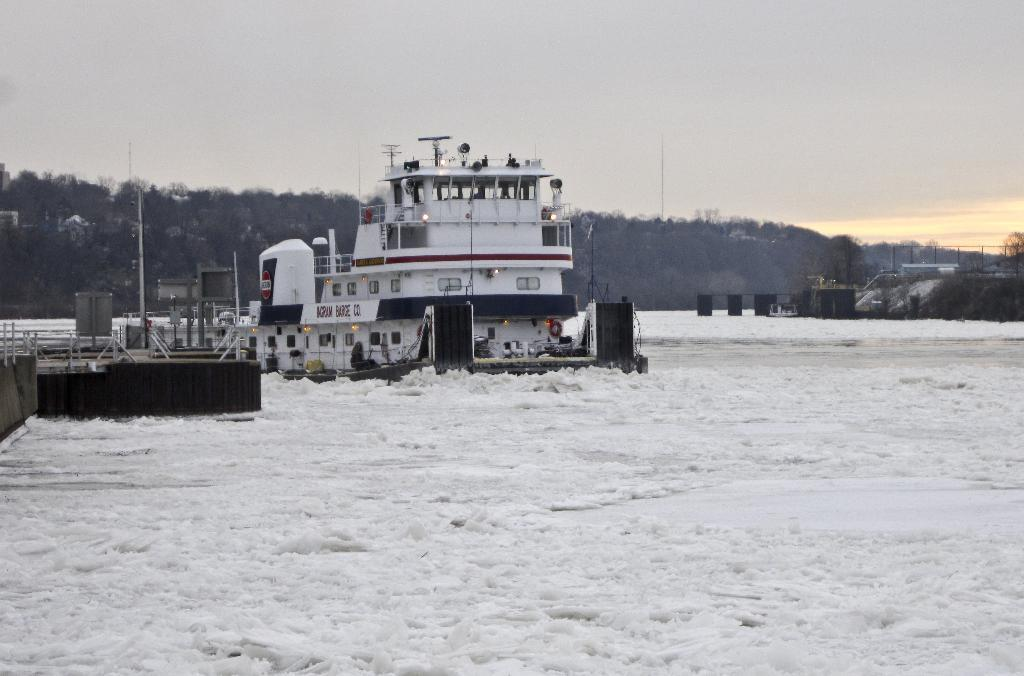What is the weather like in the image? The weather in the image is characterized by snow. What structure can be seen on the left side of the image? There is a bridge on the left side of the image. What type of vehicle is present in the image? There is a ship in the image. What type of vegetation is visible in the background of the image? There are trees in the background of the image. What is the condition of the sky in the image? The sky is clear in the image. What year is depicted in the image? The provided facts do not mention a specific year, so it cannot be determined from the image. Is the image based on a fictional setting or story? The provided facts do not indicate whether the image is based on a fictional setting or story. 